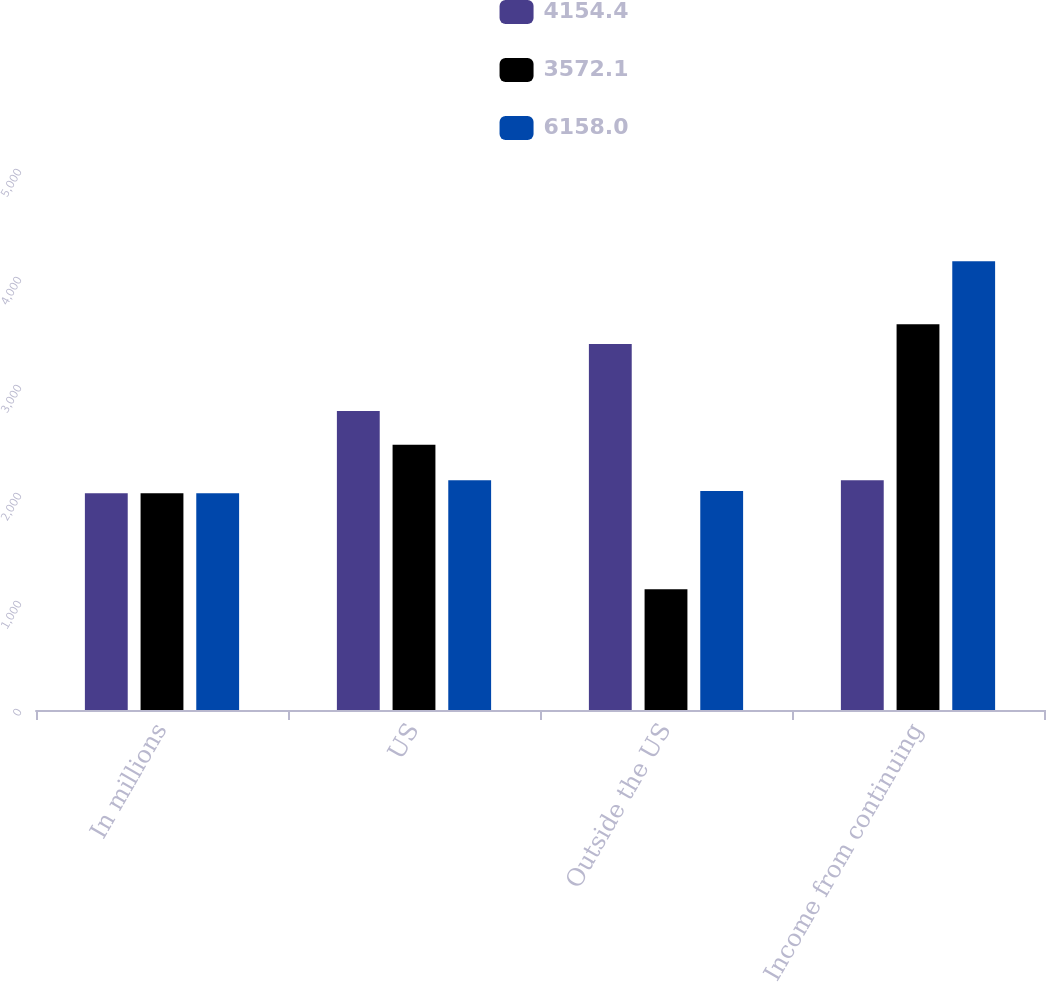Convert chart. <chart><loc_0><loc_0><loc_500><loc_500><stacked_bar_chart><ecel><fcel>In millions<fcel>US<fcel>Outside the US<fcel>Income from continuing<nl><fcel>4154.4<fcel>2008<fcel>2769.4<fcel>3388.6<fcel>2126.2<nl><fcel>3572.1<fcel>2007<fcel>2455<fcel>1117.1<fcel>3572.1<nl><fcel>6158<fcel>2006<fcel>2126.2<fcel>2028.2<fcel>4154.4<nl></chart> 